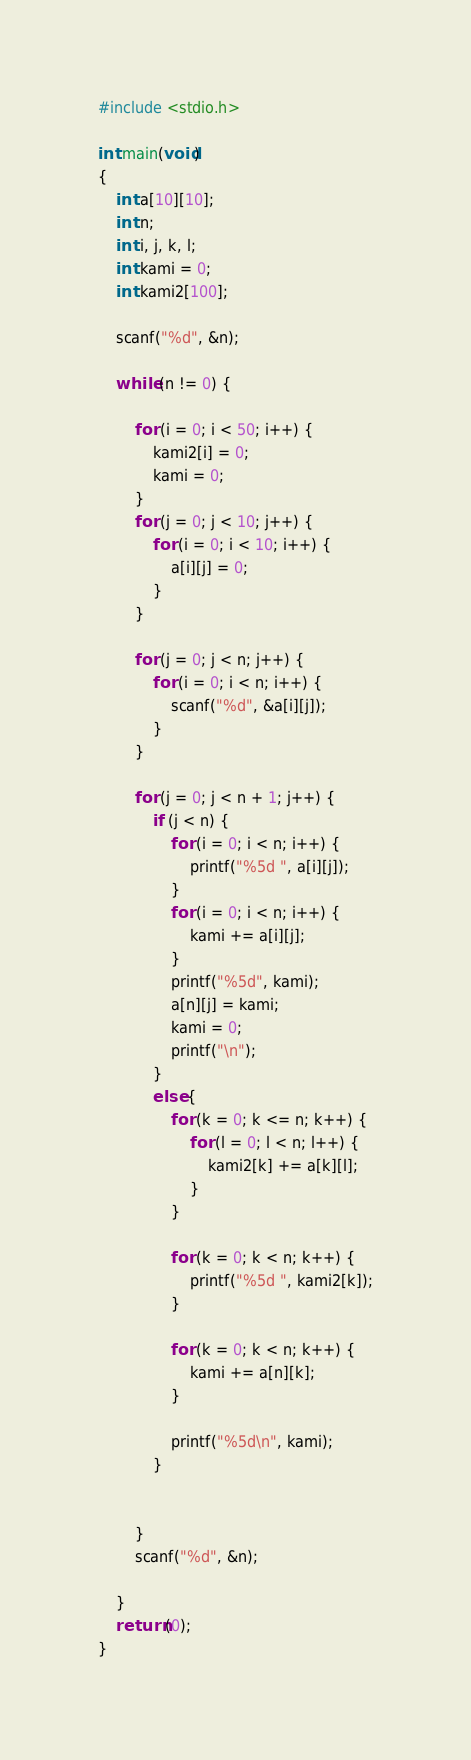Convert code to text. <code><loc_0><loc_0><loc_500><loc_500><_C_>#include <stdio.h>

int main(void)
{
	int a[10][10];
	int n;
	int i, j, k, l;
	int kami = 0;
	int kami2[100];
	
	scanf("%d", &n);
	
	while (n != 0) {
		
		for (i = 0; i < 50; i++) {
			kami2[i] = 0;
			kami = 0;
		}
		for (j = 0; j < 10; j++) {
			for (i = 0; i < 10; i++) {
				a[i][j] = 0;
			}
		}
		
		for (j = 0; j < n; j++) {
			for (i = 0; i < n; i++) {
				scanf("%d", &a[i][j]);
			}
		}
		
		for (j = 0; j < n + 1; j++) {
			if (j < n) {
				for (i = 0; i < n; i++) {
					printf("%5d ", a[i][j]);
				}
				for (i = 0; i < n; i++) {
					kami += a[i][j];
				}
				printf("%5d", kami);
				a[n][j] = kami;
				kami = 0;
				printf("\n");
			}
			else {
				for (k = 0; k <= n; k++) {
					for (l = 0; l < n; l++) {
						kami2[k] += a[k][l];
					}
				}
				
				for (k = 0; k < n; k++) {
					printf("%5d ", kami2[k]);
				}
				
				for (k = 0; k < n; k++) {
					kami += a[n][k];
				}
				
				printf("%5d\n", kami);
			}
			
			
		}
		scanf("%d", &n);
		
	}
	return (0);
}</code> 